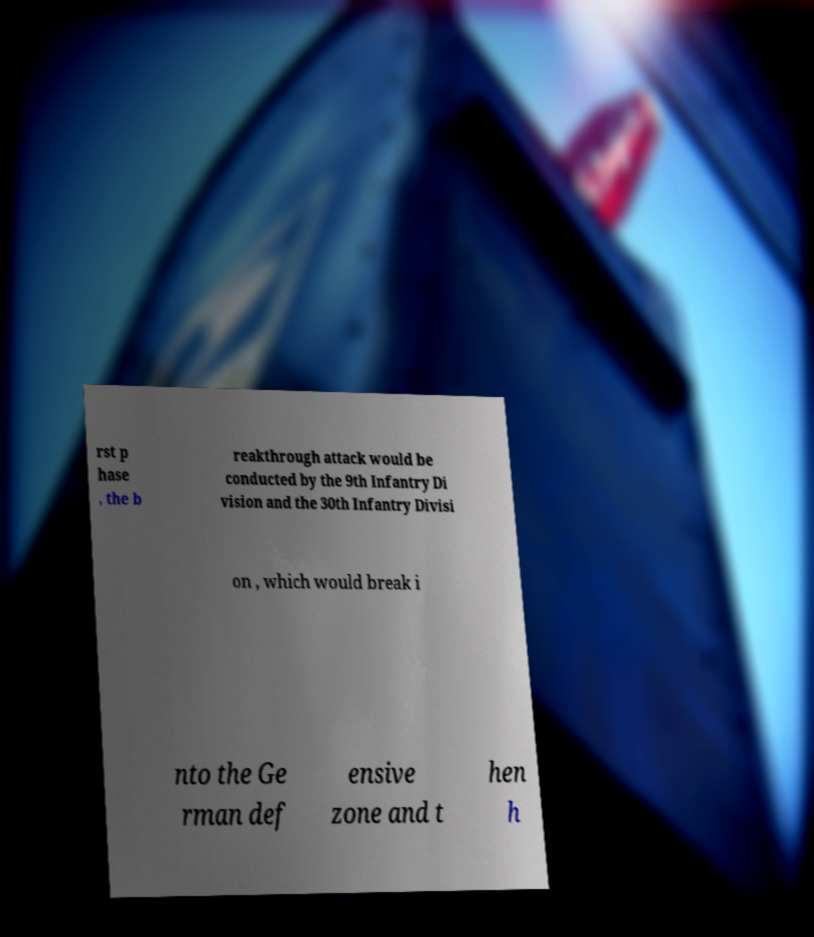I need the written content from this picture converted into text. Can you do that? rst p hase , the b reakthrough attack would be conducted by the 9th Infantry Di vision and the 30th Infantry Divisi on , which would break i nto the Ge rman def ensive zone and t hen h 